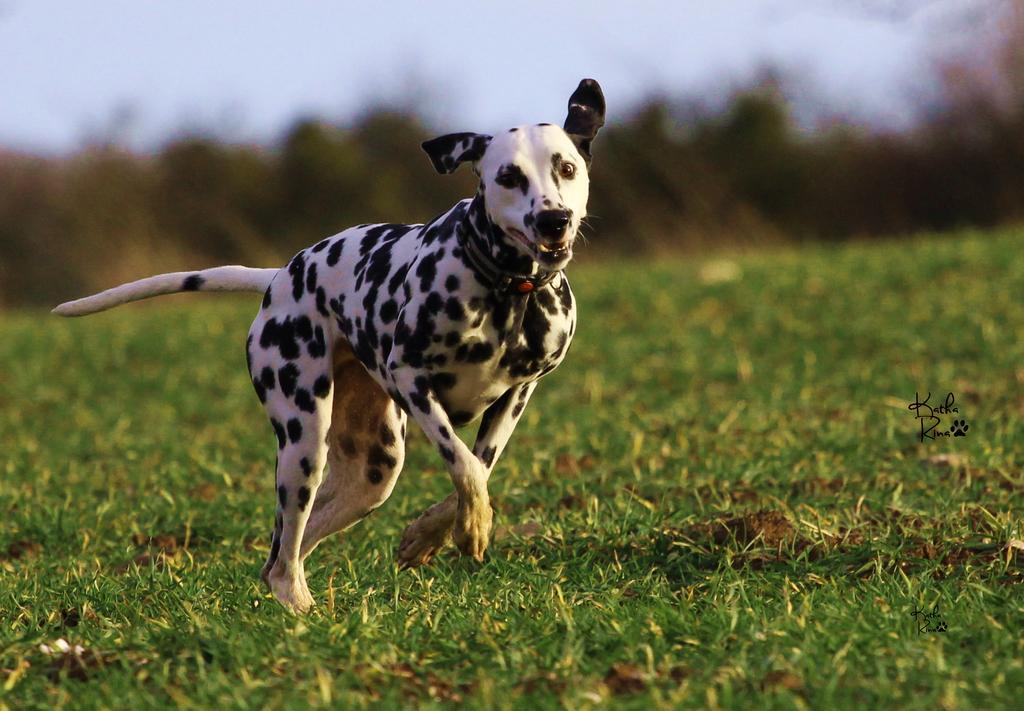Describe this image in one or two sentences. Here in this picture we can see a dalmatian running on the ground and we can see the ground is fully covered with grass and we can see the background is in blurry manner. 